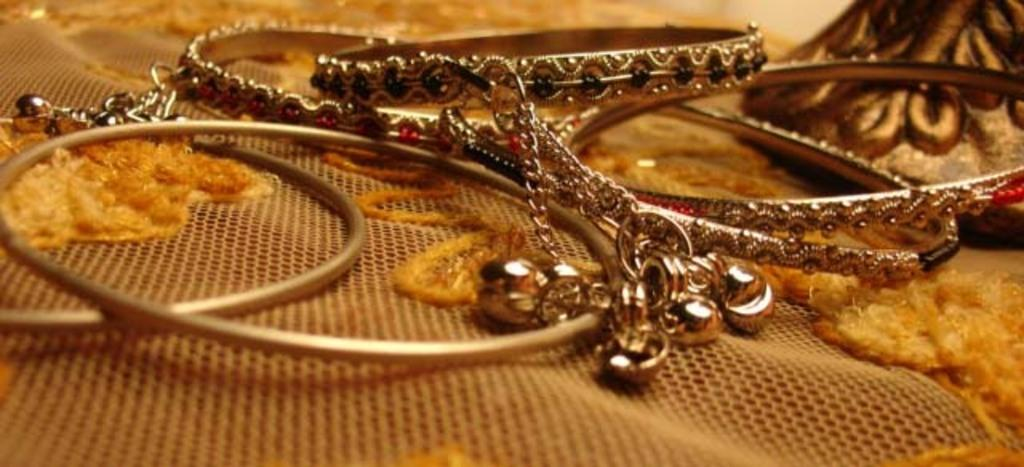What is the main subject in the foreground of the image? There are bangles in the foreground of the image. What is the bangles placed on? The bangles are placed on an embroidered net cloth. Can you describe the object in the right top of the image? Unfortunately, the provided facts do not give enough information to describe the object in the right top of the image. What color is the brain that is visible in the image? There is no brain present in the image; it features bangles placed on an embroidered net cloth. How many people are participating in the competition in the image? There is no competition present in the image. 